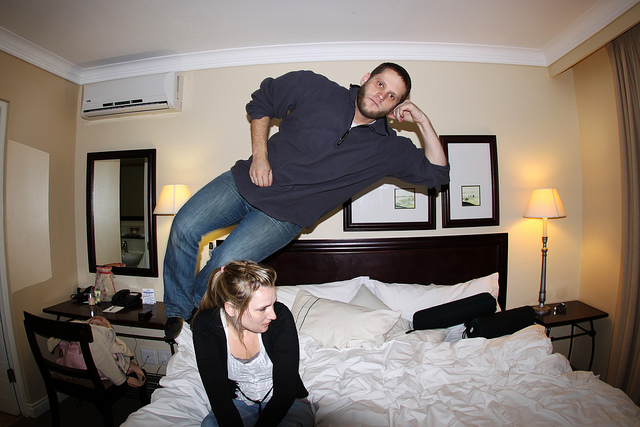What is happening in the image? The photo depicts a playful moment where one person is captured in a jump, creating the illusion that they are floating in the room, while the other person observes, seemingly entertained by the spectacle. 